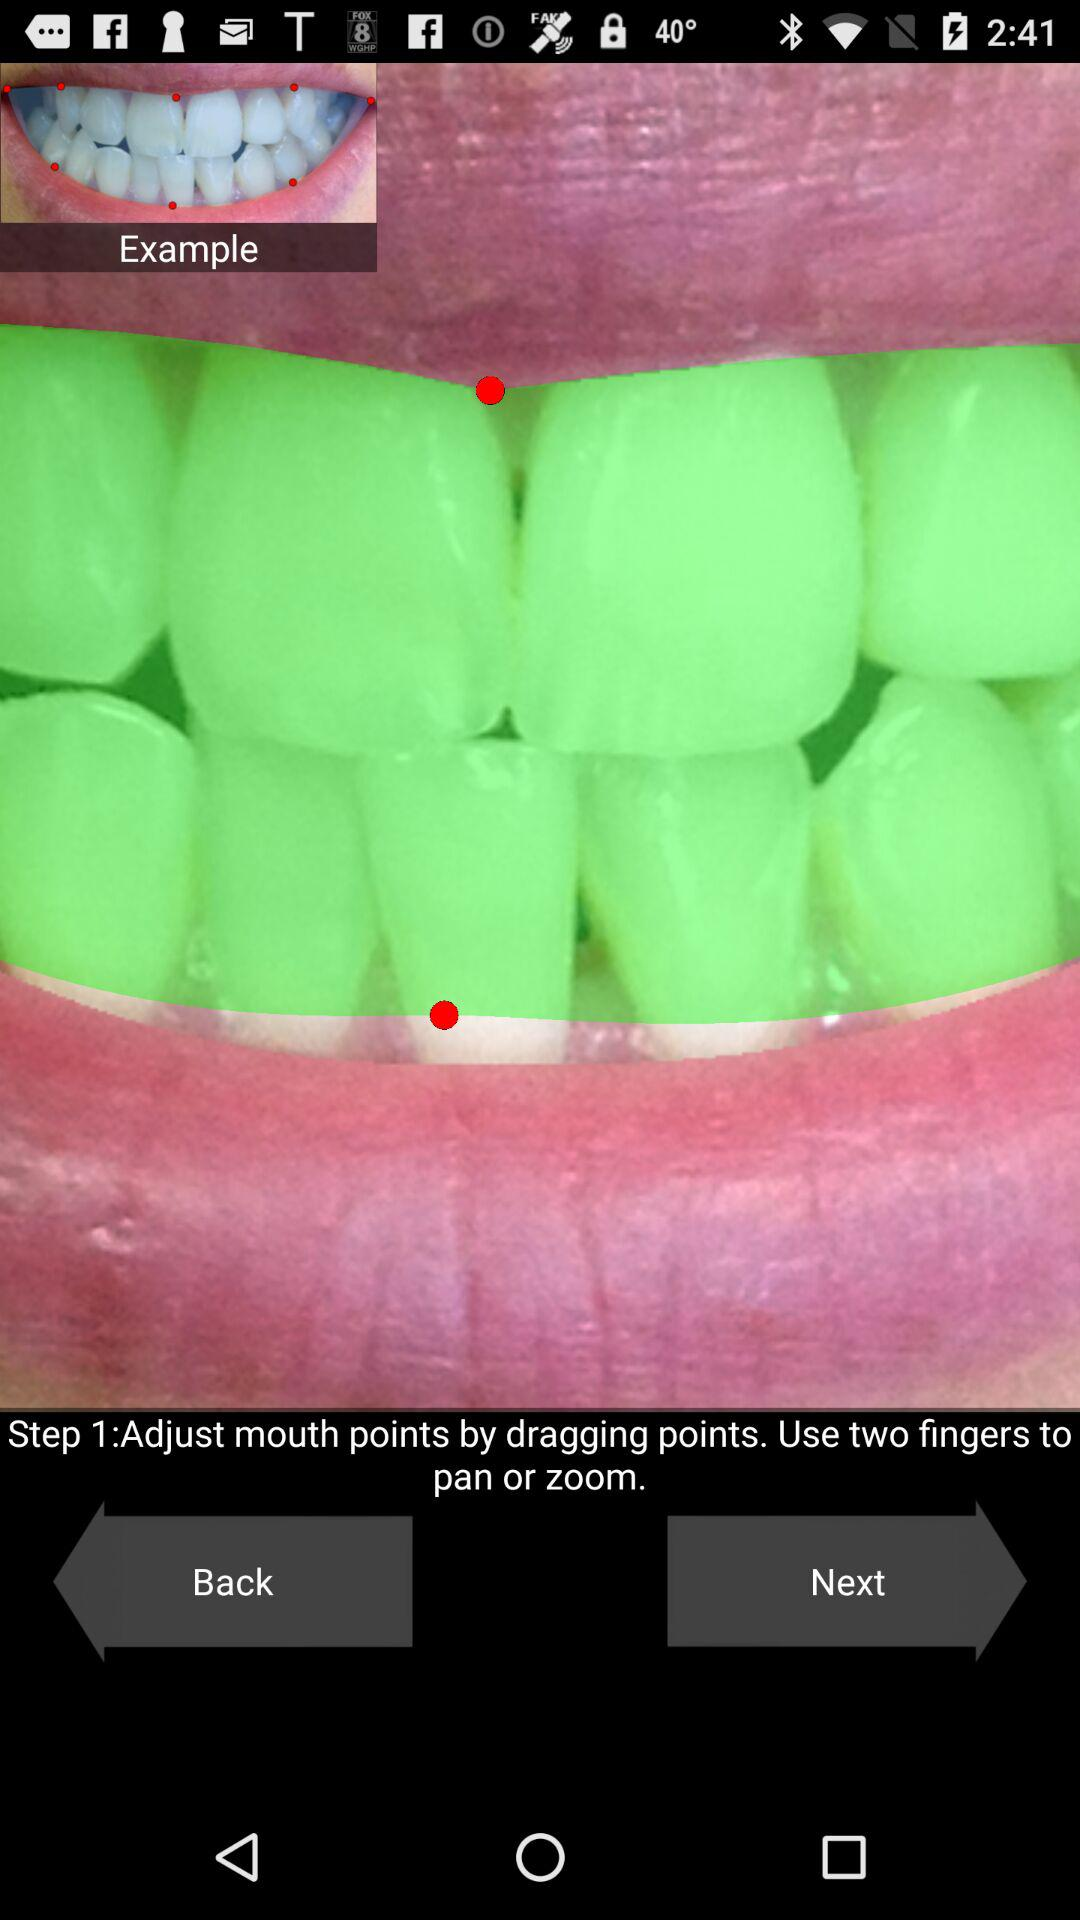How many steps are there?
Answer the question using a single word or phrase. 1 